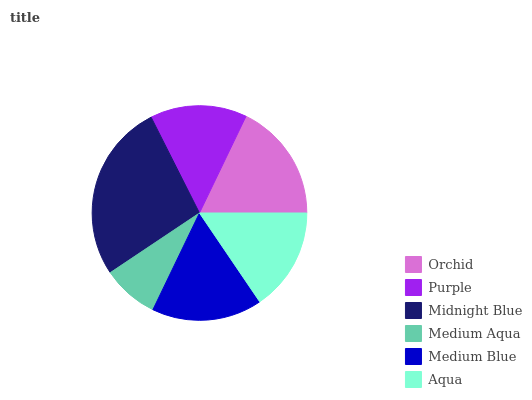Is Medium Aqua the minimum?
Answer yes or no. Yes. Is Midnight Blue the maximum?
Answer yes or no. Yes. Is Purple the minimum?
Answer yes or no. No. Is Purple the maximum?
Answer yes or no. No. Is Orchid greater than Purple?
Answer yes or no. Yes. Is Purple less than Orchid?
Answer yes or no. Yes. Is Purple greater than Orchid?
Answer yes or no. No. Is Orchid less than Purple?
Answer yes or no. No. Is Medium Blue the high median?
Answer yes or no. Yes. Is Aqua the low median?
Answer yes or no. Yes. Is Purple the high median?
Answer yes or no. No. Is Orchid the low median?
Answer yes or no. No. 